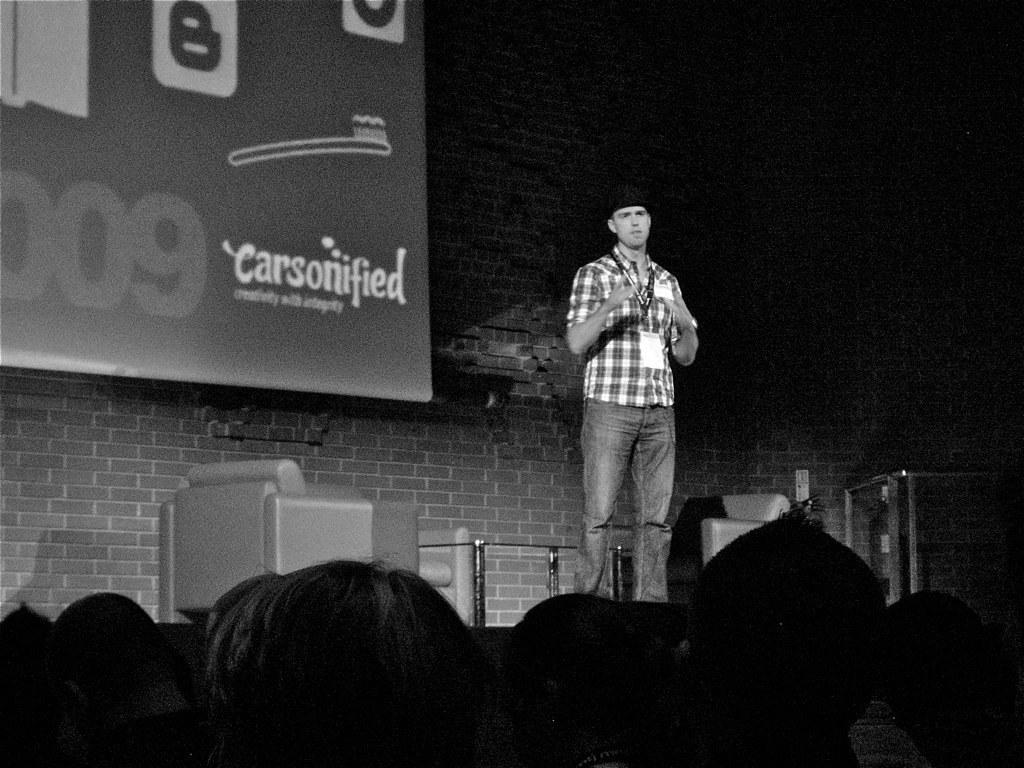In one or two sentences, can you explain what this image depicts? In the picture we can see a man standing and he is with shirt and wearing ID card and talking something and in front of him we can see some people are sitting and in the background, we can see a wall with a design on bricks and a part of banner to it with some advertisement on it. 